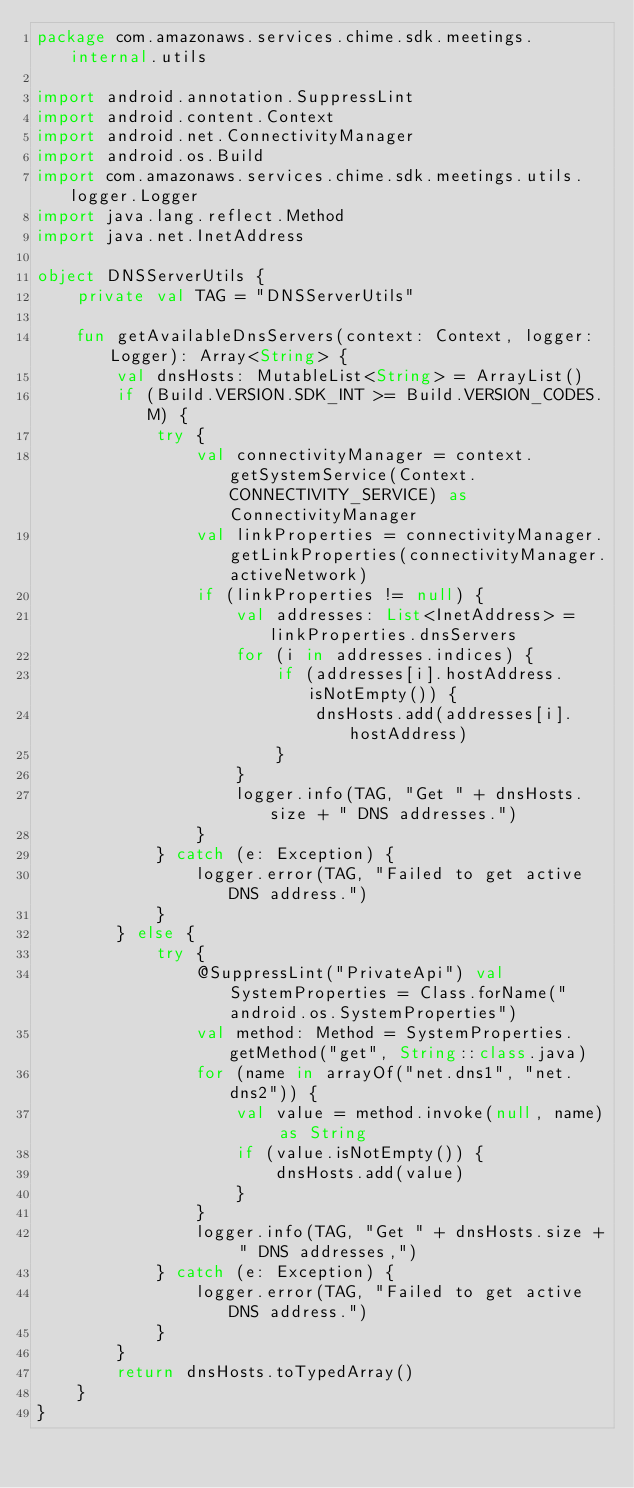Convert code to text. <code><loc_0><loc_0><loc_500><loc_500><_Kotlin_>package com.amazonaws.services.chime.sdk.meetings.internal.utils

import android.annotation.SuppressLint
import android.content.Context
import android.net.ConnectivityManager
import android.os.Build
import com.amazonaws.services.chime.sdk.meetings.utils.logger.Logger
import java.lang.reflect.Method
import java.net.InetAddress

object DNSServerUtils {
    private val TAG = "DNSServerUtils"

    fun getAvailableDnsServers(context: Context, logger: Logger): Array<String> {
        val dnsHosts: MutableList<String> = ArrayList()
        if (Build.VERSION.SDK_INT >= Build.VERSION_CODES.M) {
            try {
                val connectivityManager = context.getSystemService(Context.CONNECTIVITY_SERVICE) as ConnectivityManager
                val linkProperties = connectivityManager.getLinkProperties(connectivityManager.activeNetwork)
                if (linkProperties != null) {
                    val addresses: List<InetAddress> = linkProperties.dnsServers
                    for (i in addresses.indices) {
                        if (addresses[i].hostAddress.isNotEmpty()) {
                            dnsHosts.add(addresses[i].hostAddress)
                        }
                    }
                    logger.info(TAG, "Get " + dnsHosts.size + " DNS addresses.")
                }
            } catch (e: Exception) {
                logger.error(TAG, "Failed to get active DNS address.")
            }
        } else {
            try {
                @SuppressLint("PrivateApi") val SystemProperties = Class.forName("android.os.SystemProperties")
                val method: Method = SystemProperties.getMethod("get", String::class.java)
                for (name in arrayOf("net.dns1", "net.dns2")) {
                    val value = method.invoke(null, name) as String
                    if (value.isNotEmpty()) {
                        dnsHosts.add(value)
                    }
                }
                logger.info(TAG, "Get " + dnsHosts.size + " DNS addresses,")
            } catch (e: Exception) {
                logger.error(TAG, "Failed to get active DNS address.")
            }
        }
        return dnsHosts.toTypedArray()
    }
}
</code> 